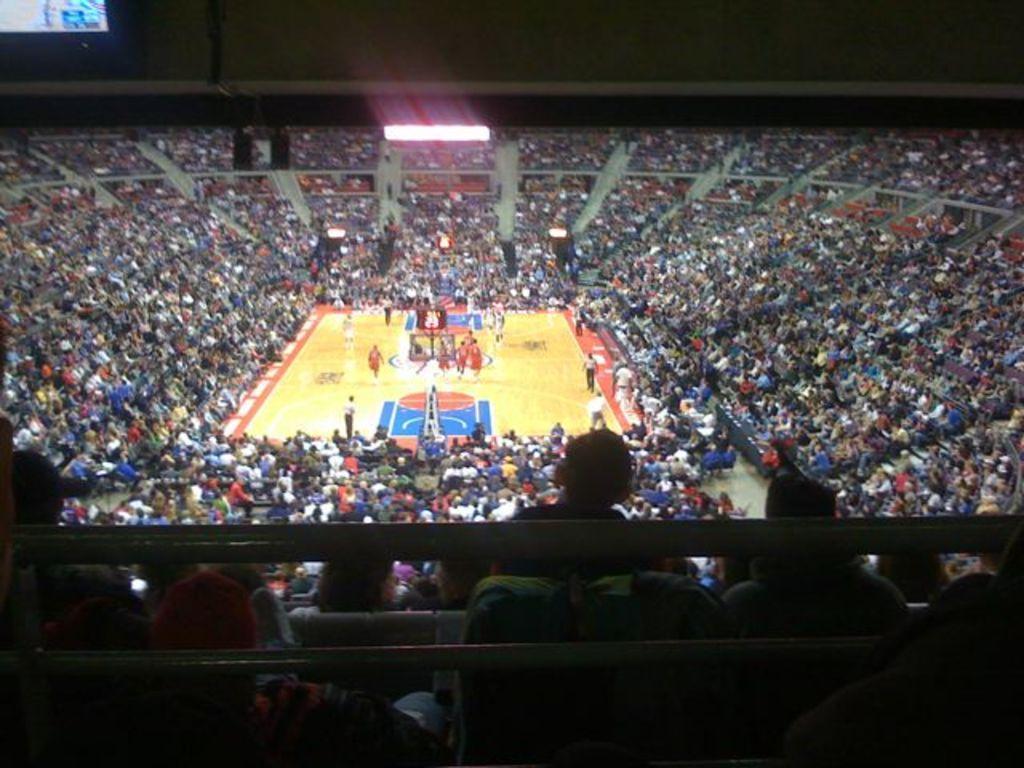Could you give a brief overview of what you see in this image? Here in this picture we can see number of people sitting in stands present over there and in the middle we can see the basketball court present, as we can see players playing the game over there and at the top we can see light present over there. 